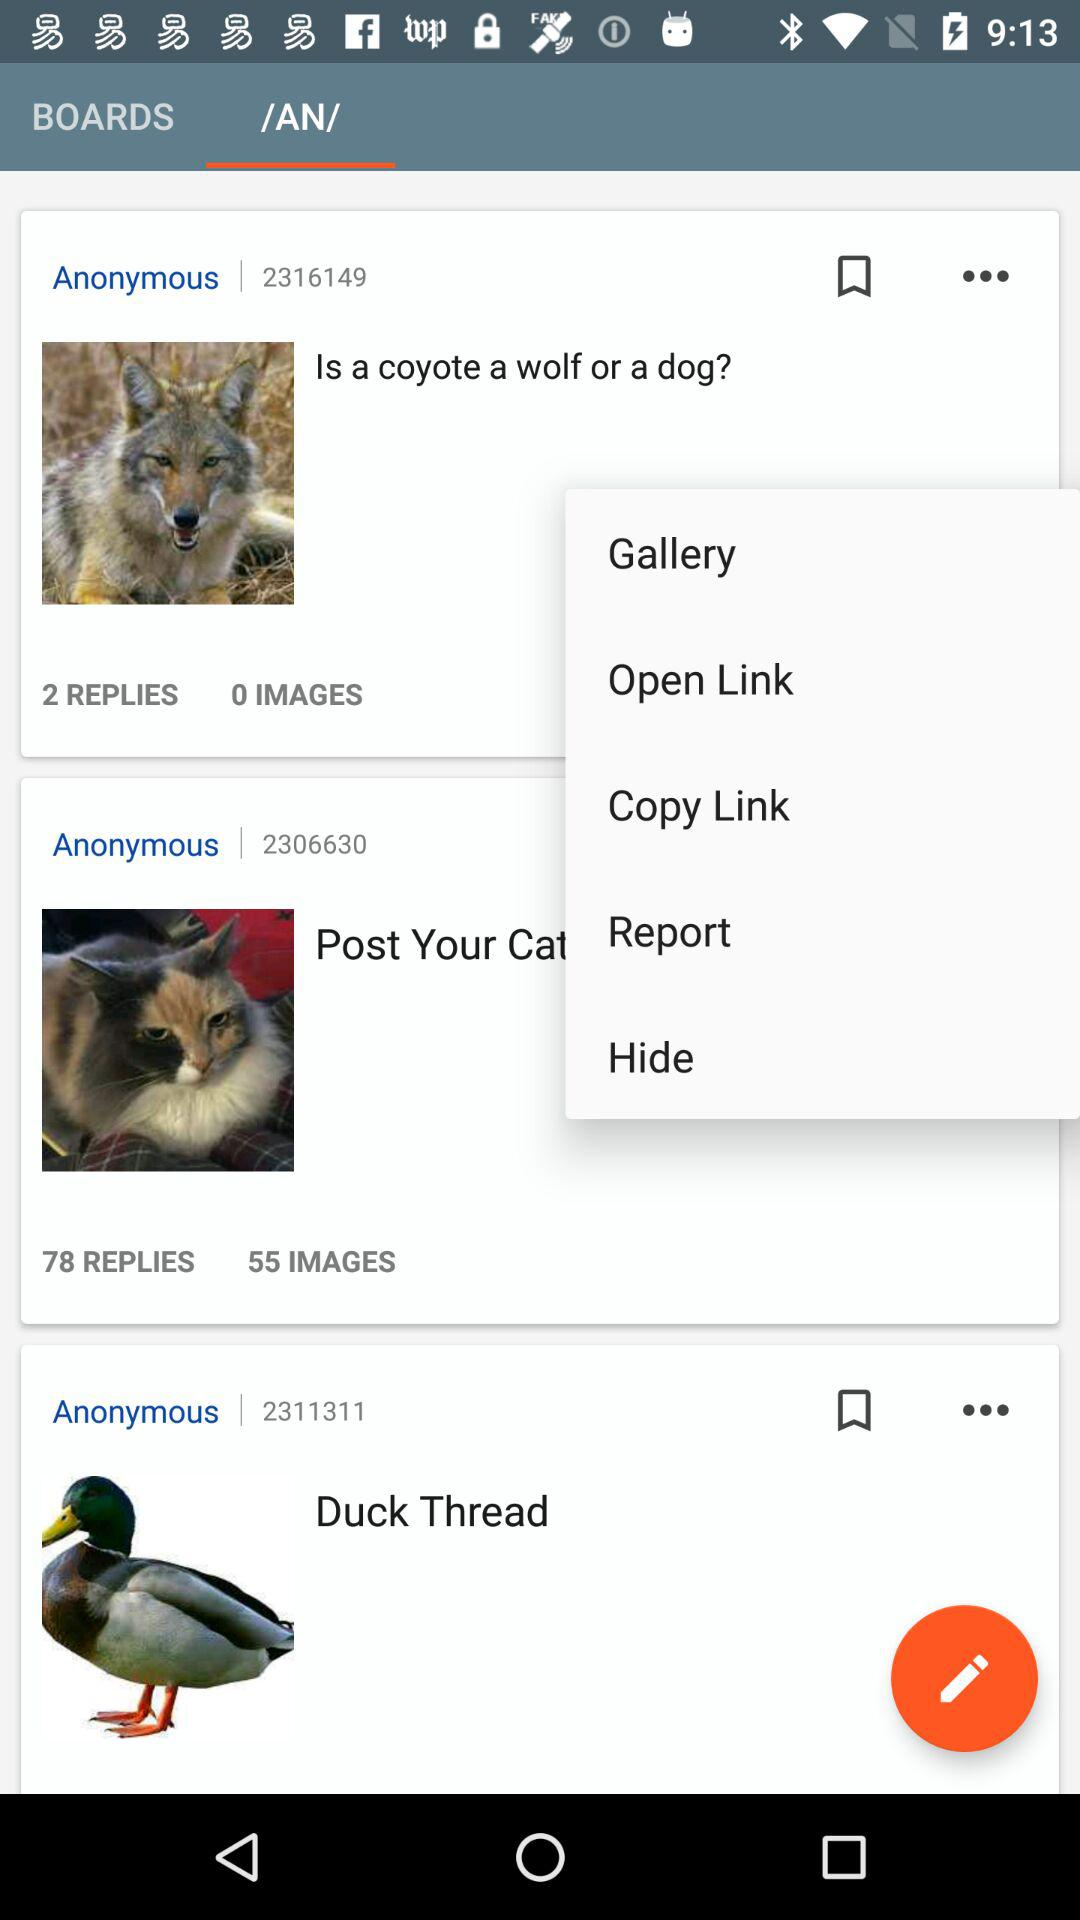What is the number for the "Duck Thread"? The number is 2311311. 